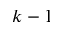<formula> <loc_0><loc_0><loc_500><loc_500>k - 1</formula> 